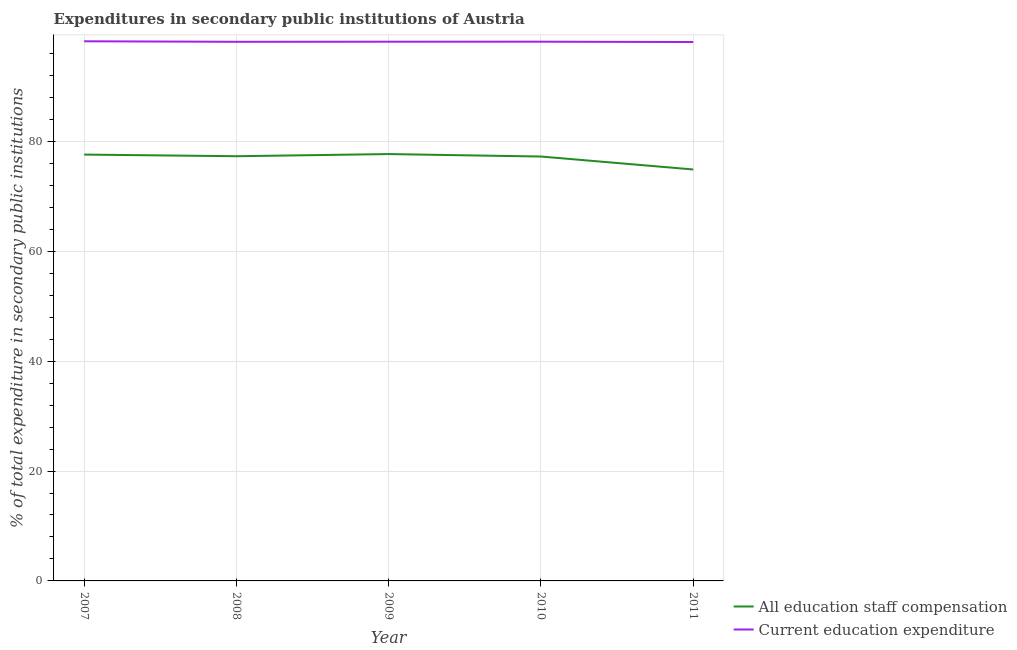How many different coloured lines are there?
Provide a succinct answer. 2. Does the line corresponding to expenditure in staff compensation intersect with the line corresponding to expenditure in education?
Your answer should be compact. No. Is the number of lines equal to the number of legend labels?
Your response must be concise. Yes. What is the expenditure in education in 2011?
Your answer should be compact. 98.08. Across all years, what is the maximum expenditure in staff compensation?
Offer a terse response. 77.68. Across all years, what is the minimum expenditure in staff compensation?
Provide a short and direct response. 74.88. In which year was the expenditure in education minimum?
Provide a succinct answer. 2011. What is the total expenditure in education in the graph?
Provide a succinct answer. 490.67. What is the difference between the expenditure in staff compensation in 2008 and that in 2010?
Your answer should be compact. 0.06. What is the difference between the expenditure in education in 2007 and the expenditure in staff compensation in 2009?
Your answer should be compact. 20.53. What is the average expenditure in education per year?
Your answer should be compact. 98.13. In the year 2007, what is the difference between the expenditure in staff compensation and expenditure in education?
Your answer should be very brief. -20.62. What is the ratio of the expenditure in staff compensation in 2008 to that in 2010?
Your response must be concise. 1. What is the difference between the highest and the second highest expenditure in education?
Your response must be concise. 0.07. What is the difference between the highest and the lowest expenditure in staff compensation?
Keep it short and to the point. 2.81. In how many years, is the expenditure in education greater than the average expenditure in education taken over all years?
Give a very brief answer. 3. Is the sum of the expenditure in education in 2008 and 2011 greater than the maximum expenditure in staff compensation across all years?
Offer a terse response. Yes. Does the expenditure in staff compensation monotonically increase over the years?
Keep it short and to the point. No. Is the expenditure in staff compensation strictly greater than the expenditure in education over the years?
Keep it short and to the point. No. Is the expenditure in staff compensation strictly less than the expenditure in education over the years?
Make the answer very short. Yes. How many lines are there?
Provide a short and direct response. 2. How many years are there in the graph?
Offer a terse response. 5. Does the graph contain grids?
Ensure brevity in your answer.  Yes. How many legend labels are there?
Provide a succinct answer. 2. What is the title of the graph?
Keep it short and to the point. Expenditures in secondary public institutions of Austria. What is the label or title of the X-axis?
Offer a very short reply. Year. What is the label or title of the Y-axis?
Keep it short and to the point. % of total expenditure in secondary public institutions. What is the % of total expenditure in secondary public institutions in All education staff compensation in 2007?
Offer a terse response. 77.59. What is the % of total expenditure in secondary public institutions of Current education expenditure in 2007?
Make the answer very short. 98.21. What is the % of total expenditure in secondary public institutions of All education staff compensation in 2008?
Ensure brevity in your answer.  77.29. What is the % of total expenditure in secondary public institutions of Current education expenditure in 2008?
Offer a very short reply. 98.12. What is the % of total expenditure in secondary public institutions of All education staff compensation in 2009?
Provide a succinct answer. 77.68. What is the % of total expenditure in secondary public institutions in Current education expenditure in 2009?
Provide a short and direct response. 98.14. What is the % of total expenditure in secondary public institutions in All education staff compensation in 2010?
Offer a terse response. 77.24. What is the % of total expenditure in secondary public institutions in Current education expenditure in 2010?
Provide a short and direct response. 98.14. What is the % of total expenditure in secondary public institutions in All education staff compensation in 2011?
Ensure brevity in your answer.  74.88. What is the % of total expenditure in secondary public institutions in Current education expenditure in 2011?
Keep it short and to the point. 98.08. Across all years, what is the maximum % of total expenditure in secondary public institutions in All education staff compensation?
Give a very brief answer. 77.68. Across all years, what is the maximum % of total expenditure in secondary public institutions in Current education expenditure?
Provide a short and direct response. 98.21. Across all years, what is the minimum % of total expenditure in secondary public institutions in All education staff compensation?
Keep it short and to the point. 74.88. Across all years, what is the minimum % of total expenditure in secondary public institutions of Current education expenditure?
Ensure brevity in your answer.  98.08. What is the total % of total expenditure in secondary public institutions of All education staff compensation in the graph?
Keep it short and to the point. 384.68. What is the total % of total expenditure in secondary public institutions of Current education expenditure in the graph?
Ensure brevity in your answer.  490.67. What is the difference between the % of total expenditure in secondary public institutions in All education staff compensation in 2007 and that in 2008?
Provide a short and direct response. 0.3. What is the difference between the % of total expenditure in secondary public institutions of Current education expenditure in 2007 and that in 2008?
Offer a terse response. 0.09. What is the difference between the % of total expenditure in secondary public institutions in All education staff compensation in 2007 and that in 2009?
Keep it short and to the point. -0.09. What is the difference between the % of total expenditure in secondary public institutions of Current education expenditure in 2007 and that in 2009?
Give a very brief answer. 0.07. What is the difference between the % of total expenditure in secondary public institutions of All education staff compensation in 2007 and that in 2010?
Offer a terse response. 0.35. What is the difference between the % of total expenditure in secondary public institutions of Current education expenditure in 2007 and that in 2010?
Your answer should be very brief. 0.07. What is the difference between the % of total expenditure in secondary public institutions in All education staff compensation in 2007 and that in 2011?
Your response must be concise. 2.71. What is the difference between the % of total expenditure in secondary public institutions in Current education expenditure in 2007 and that in 2011?
Make the answer very short. 0.13. What is the difference between the % of total expenditure in secondary public institutions in All education staff compensation in 2008 and that in 2009?
Provide a short and direct response. -0.39. What is the difference between the % of total expenditure in secondary public institutions in Current education expenditure in 2008 and that in 2009?
Offer a terse response. -0.02. What is the difference between the % of total expenditure in secondary public institutions of All education staff compensation in 2008 and that in 2010?
Your answer should be compact. 0.06. What is the difference between the % of total expenditure in secondary public institutions of Current education expenditure in 2008 and that in 2010?
Ensure brevity in your answer.  -0.02. What is the difference between the % of total expenditure in secondary public institutions of All education staff compensation in 2008 and that in 2011?
Ensure brevity in your answer.  2.41. What is the difference between the % of total expenditure in secondary public institutions in Current education expenditure in 2008 and that in 2011?
Provide a succinct answer. 0.04. What is the difference between the % of total expenditure in secondary public institutions in All education staff compensation in 2009 and that in 2010?
Ensure brevity in your answer.  0.45. What is the difference between the % of total expenditure in secondary public institutions in Current education expenditure in 2009 and that in 2010?
Your answer should be very brief. -0. What is the difference between the % of total expenditure in secondary public institutions of All education staff compensation in 2009 and that in 2011?
Make the answer very short. 2.81. What is the difference between the % of total expenditure in secondary public institutions of Current education expenditure in 2009 and that in 2011?
Offer a very short reply. 0.06. What is the difference between the % of total expenditure in secondary public institutions of All education staff compensation in 2010 and that in 2011?
Make the answer very short. 2.36. What is the difference between the % of total expenditure in secondary public institutions of Current education expenditure in 2010 and that in 2011?
Your answer should be very brief. 0.06. What is the difference between the % of total expenditure in secondary public institutions of All education staff compensation in 2007 and the % of total expenditure in secondary public institutions of Current education expenditure in 2008?
Your answer should be very brief. -20.53. What is the difference between the % of total expenditure in secondary public institutions in All education staff compensation in 2007 and the % of total expenditure in secondary public institutions in Current education expenditure in 2009?
Your response must be concise. -20.54. What is the difference between the % of total expenditure in secondary public institutions in All education staff compensation in 2007 and the % of total expenditure in secondary public institutions in Current education expenditure in 2010?
Ensure brevity in your answer.  -20.54. What is the difference between the % of total expenditure in secondary public institutions in All education staff compensation in 2007 and the % of total expenditure in secondary public institutions in Current education expenditure in 2011?
Your answer should be compact. -20.48. What is the difference between the % of total expenditure in secondary public institutions in All education staff compensation in 2008 and the % of total expenditure in secondary public institutions in Current education expenditure in 2009?
Your response must be concise. -20.84. What is the difference between the % of total expenditure in secondary public institutions of All education staff compensation in 2008 and the % of total expenditure in secondary public institutions of Current education expenditure in 2010?
Offer a very short reply. -20.84. What is the difference between the % of total expenditure in secondary public institutions of All education staff compensation in 2008 and the % of total expenditure in secondary public institutions of Current education expenditure in 2011?
Your answer should be compact. -20.78. What is the difference between the % of total expenditure in secondary public institutions in All education staff compensation in 2009 and the % of total expenditure in secondary public institutions in Current education expenditure in 2010?
Keep it short and to the point. -20.45. What is the difference between the % of total expenditure in secondary public institutions of All education staff compensation in 2009 and the % of total expenditure in secondary public institutions of Current education expenditure in 2011?
Your answer should be compact. -20.39. What is the difference between the % of total expenditure in secondary public institutions of All education staff compensation in 2010 and the % of total expenditure in secondary public institutions of Current education expenditure in 2011?
Give a very brief answer. -20.84. What is the average % of total expenditure in secondary public institutions of All education staff compensation per year?
Ensure brevity in your answer.  76.94. What is the average % of total expenditure in secondary public institutions of Current education expenditure per year?
Ensure brevity in your answer.  98.13. In the year 2007, what is the difference between the % of total expenditure in secondary public institutions of All education staff compensation and % of total expenditure in secondary public institutions of Current education expenditure?
Your answer should be compact. -20.62. In the year 2008, what is the difference between the % of total expenditure in secondary public institutions in All education staff compensation and % of total expenditure in secondary public institutions in Current education expenditure?
Your response must be concise. -20.83. In the year 2009, what is the difference between the % of total expenditure in secondary public institutions of All education staff compensation and % of total expenditure in secondary public institutions of Current education expenditure?
Keep it short and to the point. -20.45. In the year 2010, what is the difference between the % of total expenditure in secondary public institutions of All education staff compensation and % of total expenditure in secondary public institutions of Current education expenditure?
Your response must be concise. -20.9. In the year 2011, what is the difference between the % of total expenditure in secondary public institutions in All education staff compensation and % of total expenditure in secondary public institutions in Current education expenditure?
Ensure brevity in your answer.  -23.2. What is the ratio of the % of total expenditure in secondary public institutions in All education staff compensation in 2007 to that in 2008?
Ensure brevity in your answer.  1. What is the ratio of the % of total expenditure in secondary public institutions in Current education expenditure in 2007 to that in 2009?
Offer a terse response. 1. What is the ratio of the % of total expenditure in secondary public institutions of All education staff compensation in 2007 to that in 2011?
Ensure brevity in your answer.  1.04. What is the ratio of the % of total expenditure in secondary public institutions in All education staff compensation in 2008 to that in 2010?
Offer a very short reply. 1. What is the ratio of the % of total expenditure in secondary public institutions of All education staff compensation in 2008 to that in 2011?
Make the answer very short. 1.03. What is the ratio of the % of total expenditure in secondary public institutions in All education staff compensation in 2009 to that in 2010?
Your response must be concise. 1.01. What is the ratio of the % of total expenditure in secondary public institutions in Current education expenditure in 2009 to that in 2010?
Offer a very short reply. 1. What is the ratio of the % of total expenditure in secondary public institutions in All education staff compensation in 2009 to that in 2011?
Offer a terse response. 1.04. What is the ratio of the % of total expenditure in secondary public institutions in Current education expenditure in 2009 to that in 2011?
Offer a terse response. 1. What is the ratio of the % of total expenditure in secondary public institutions of All education staff compensation in 2010 to that in 2011?
Make the answer very short. 1.03. What is the ratio of the % of total expenditure in secondary public institutions in Current education expenditure in 2010 to that in 2011?
Make the answer very short. 1. What is the difference between the highest and the second highest % of total expenditure in secondary public institutions of All education staff compensation?
Your response must be concise. 0.09. What is the difference between the highest and the second highest % of total expenditure in secondary public institutions in Current education expenditure?
Make the answer very short. 0.07. What is the difference between the highest and the lowest % of total expenditure in secondary public institutions in All education staff compensation?
Offer a terse response. 2.81. What is the difference between the highest and the lowest % of total expenditure in secondary public institutions in Current education expenditure?
Ensure brevity in your answer.  0.13. 